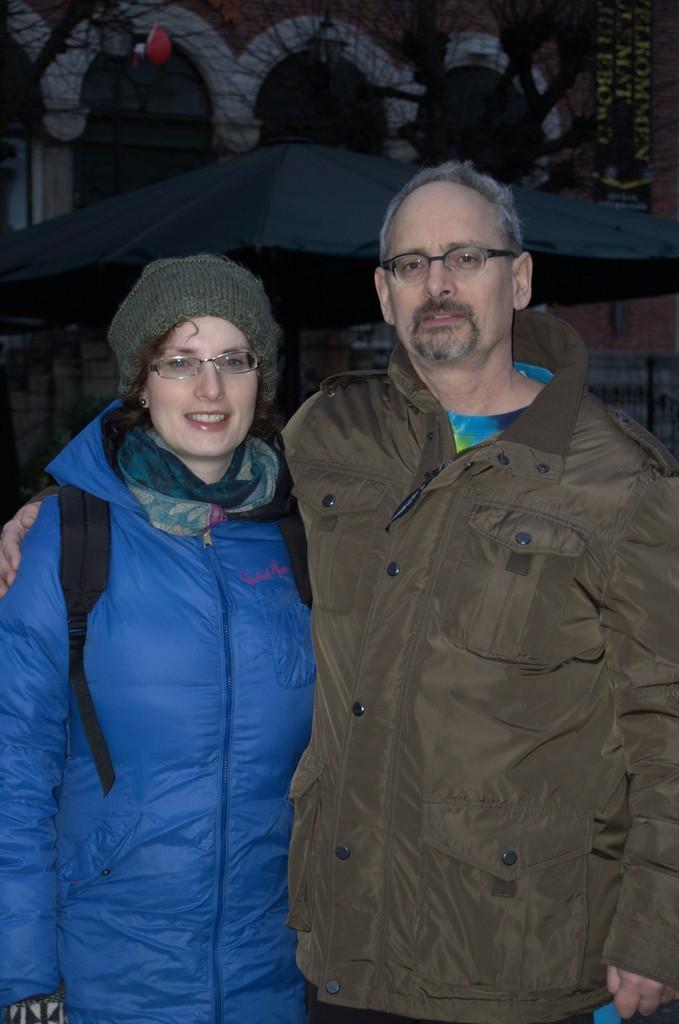In one or two sentences, can you explain what this image depicts? In this image we can see a man and a woman standing on the floor. In the background there are buildings. 